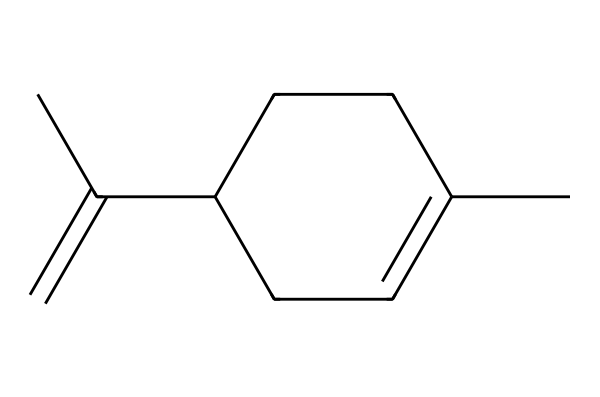What is the molecular formula of limonene? To determine the molecular formula, count the number of carbon (C) and hydrogen (H) atoms in the chemical structure based on the SMILES representation. There are 10 carbon atoms and 16 hydrogen atoms, leading to the formula C10H16.
Answer: C10H16 How many double bonds are present in the structure? The structure can be analyzed for double bonds by identifying which connections between atoms are not single bonds. In limonene, there is one double bond indicated by the "=" symbol in the SMILES representation.
Answer: 1 What type of isomerism is limonene known for? Limonene exists as two enantiomers due to its chiral centers. Looking at the molecular structure, we can discern that it has the potential for optical isomerism, thus it is known for being chiral.
Answer: optical What is the feature of terpenes that limonene demonstrates? Limonene is classified as a terpene, which is characterized by a specific arrangement of carbon and hydrogen atoms that often provides aromatic qualities. In this structure, the distinctive open chain and cyclical structures typical of terpenes are evident.
Answer: aromatic How many rings are in the limonene structure? The SMILES representation indicates that limonene has a cyclic structure. Examining the structure shows that it contains one ring composed of five carbon atoms.
Answer: 1 What functional group is associated with limonene? The presence of double bonds in the structure indicates possible functional groups. While limonene primarily features a hydrocarbon backbone, the double bond classifies it as an alkene, which is a type of functional group commonly found in terpenes.
Answer: alkene 